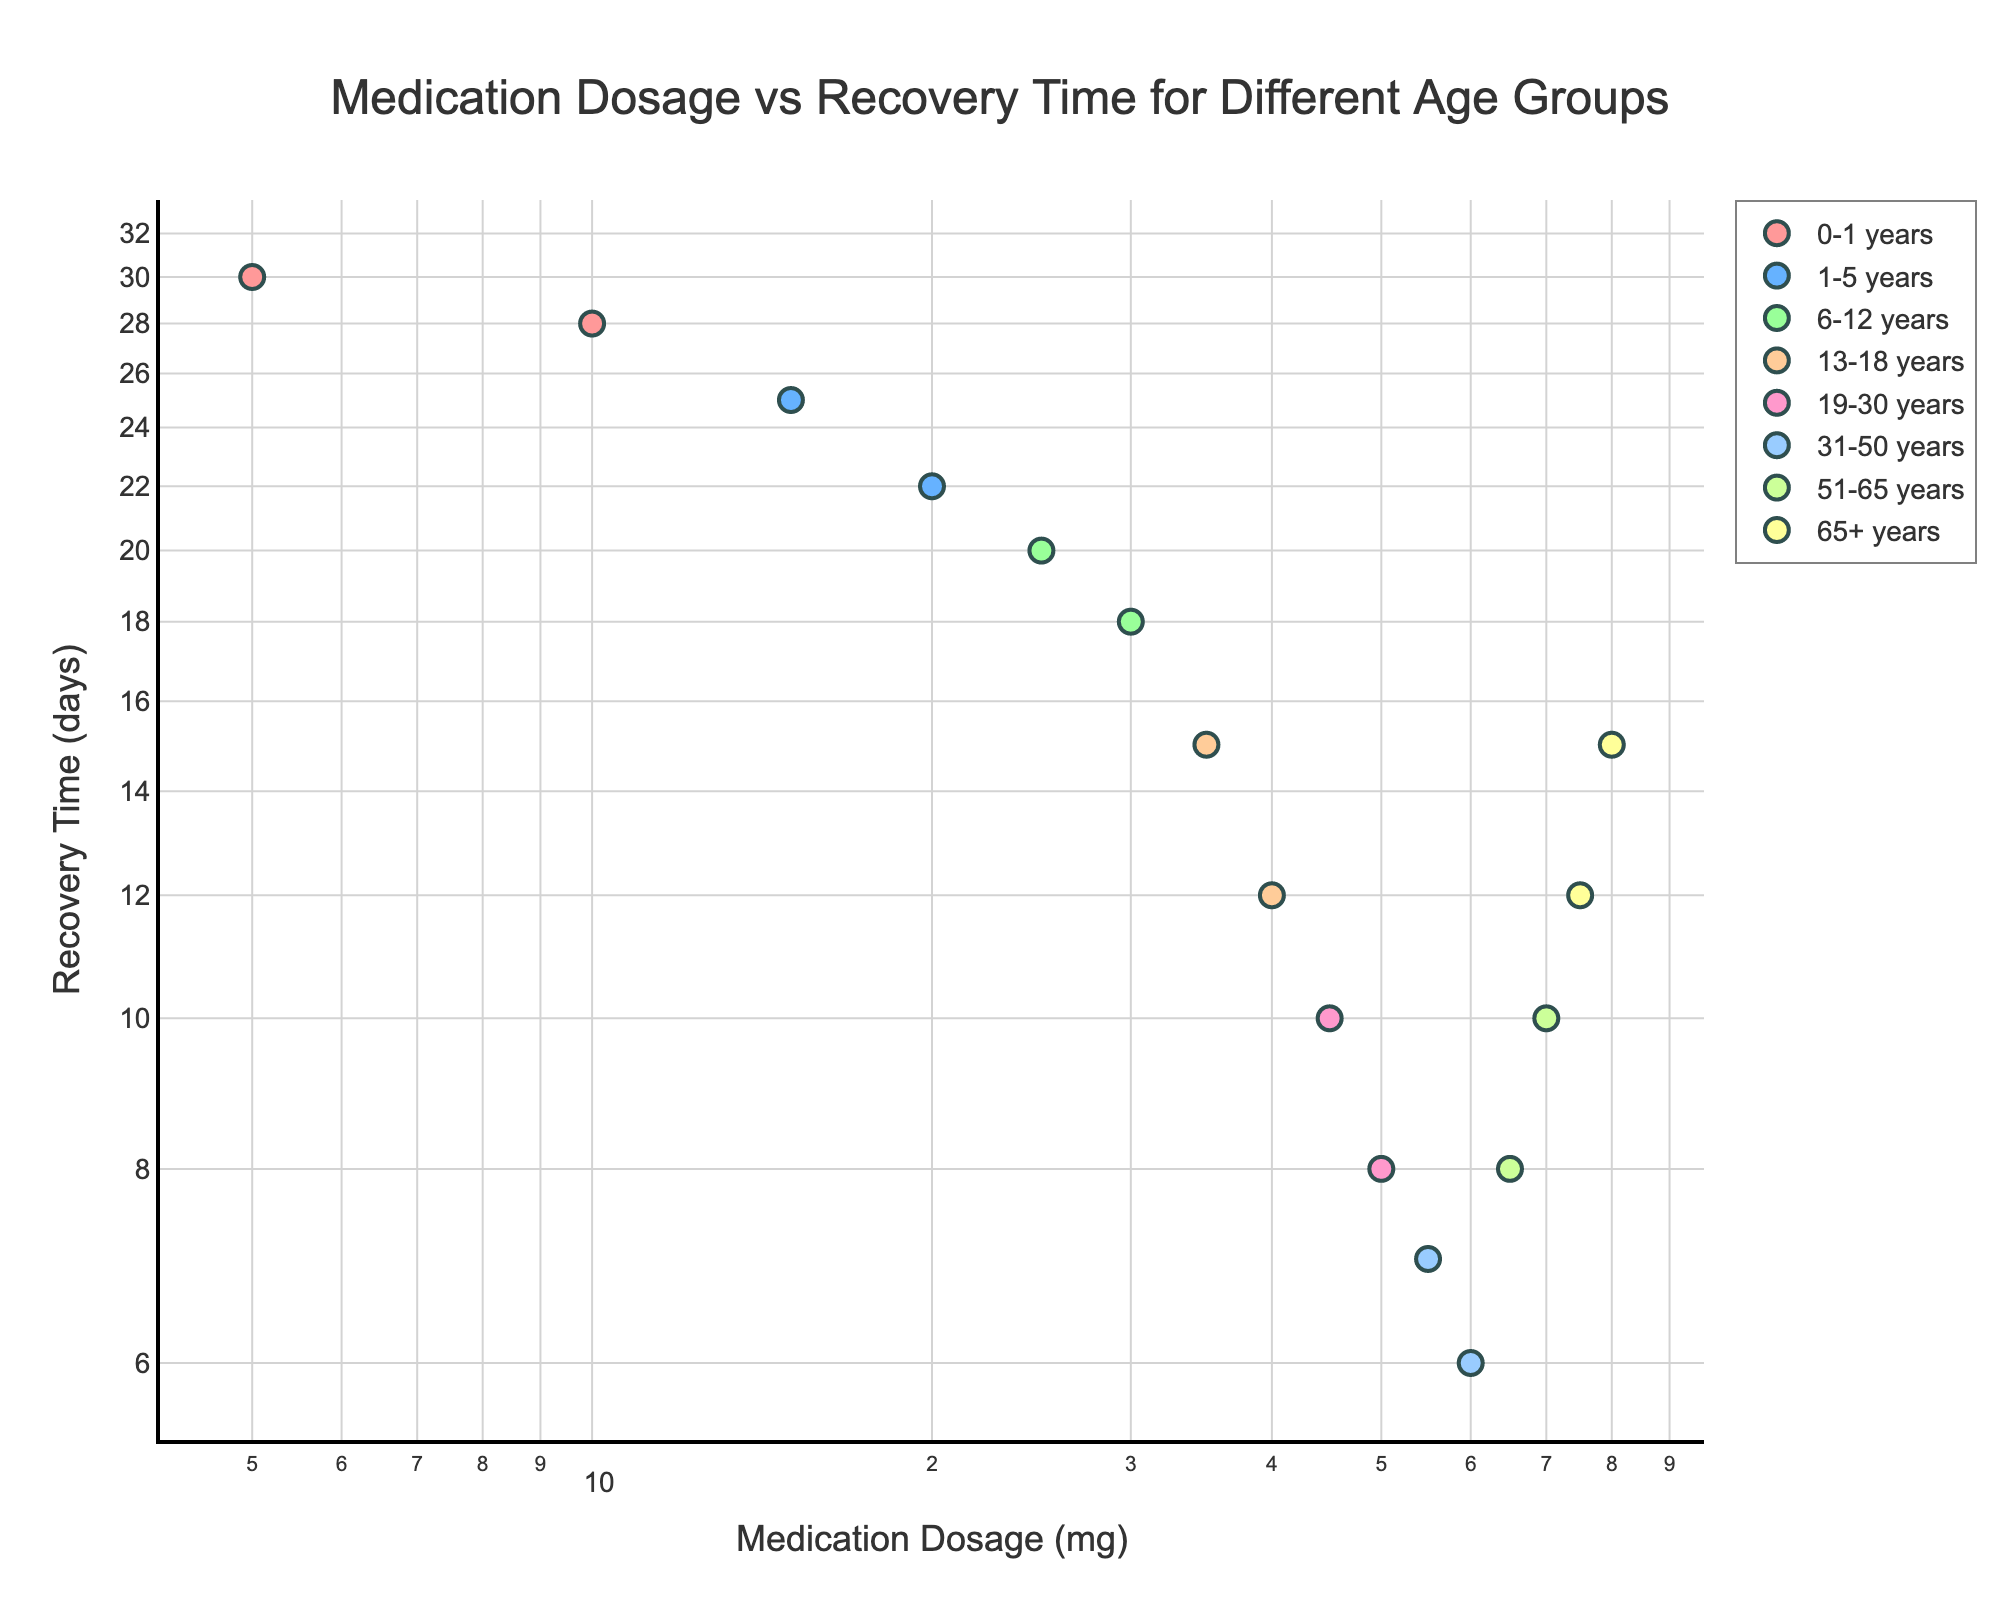What is the title of the scatter plot? The title is usually displayed at the top of the plot. In this case, the title is "Medication Dosage vs Recovery Time for Different Age Groups."
Answer: Medication Dosage vs Recovery Time for Different Age Groups Which age group has the data points with the highest dosage? To answer this, locate the data points with the highest values on the x-axis (which represents Medication Dosage (mg)). The age group with the highest dosages (75 mg and 80 mg) is "65+ years."
Answer: 65+ years What is the recovery time for the 31-50 years age group at a dosage of 55 mg? Look for the data point within the 31-50 years age group that corresponds to a dosage of 55 mg on the x-axis. The corresponding y-value (Recovery Time) is 7 days.
Answer: 7 days How does the recovery time change as the dosage increases for the 0-1 years age group? For the 0-1 years age group, identify the data points and observe the trend as the dosage increases from 5 mg to 10 mg. The recovery time decreases from 30 days to 28 days.
Answer: Decreases At which dosages do the 19-30 years age group have their data points? Locate the data points associated with the 19-30 years age group and read off their x-values (Medication Dosage). The dosages are 45 mg and 50 mg.
Answer: 45 mg and 50 mg What is the relationship between medication dosage and recovery time for the 6-12 years age group shown in the plot? Identify the data points for the 6-12 years age group and analyze the trend between the x-axis (dosage) and y-axis (recovery time). As the dosage increases from 25 mg to 30 mg, the recovery time decreases from 20 days to 18 days.
Answer: Inverse relationship Compare the recovery times for the 13-18 years and 65+ years age groups at their lowest dosages. Which group recovers faster? For the 13-18 years group at 35 mg (lowest dosage), the recovery time is 15 days. For the 65+ years group at 75 mg (lowest dosage), the recovery time is 12 days. The 65+ years group recovers faster.
Answer: 65+ years Which age group shows the highest recovery time variability? To determine this, compare the ranges (differences between highest and lowest recovery times) for each age group. The 0-1 years group shows a recovery time range from 28 to 30 days, which is 2 days. The 1-5 years group ranges from 22 to 25 days (3 days). The 6-12 years group ranges from 18 to 20 days (2 days). The 13-18 years group ranges from 12 to 15 days (3 days). The 19-30 years group ranges from 8 to 10 days (2 days). The 31-50 years group ranges from 6 to 7 days (1 day). The 51-65 years group ranges from 8 to 10 days (2 days). The 65+ years group ranges from 12 to 15 days (3 days). Hence, the highest variability is in the 1-5 years, 13-18 years, and 65+ years groups, each with 3 days range.
Answer: 1-5 years, 13-18 years, and 65+ years What is the color used for the 19-30 years age group in the scatter plot? Each age group is represented by a different color. The 19-30 years age group is represented by one of the colors: '#FF9999', '#66B2FF', '#99FF99', '#FFCC99', '#FF99CC', '#99CCFF', '#CCFF99', '#FFFF99'. Identify the color directly associated with the 19-30 years group in the plot. Typically, the third color in the sequence, which is '#99FF99'.
Answer: A shade of green 